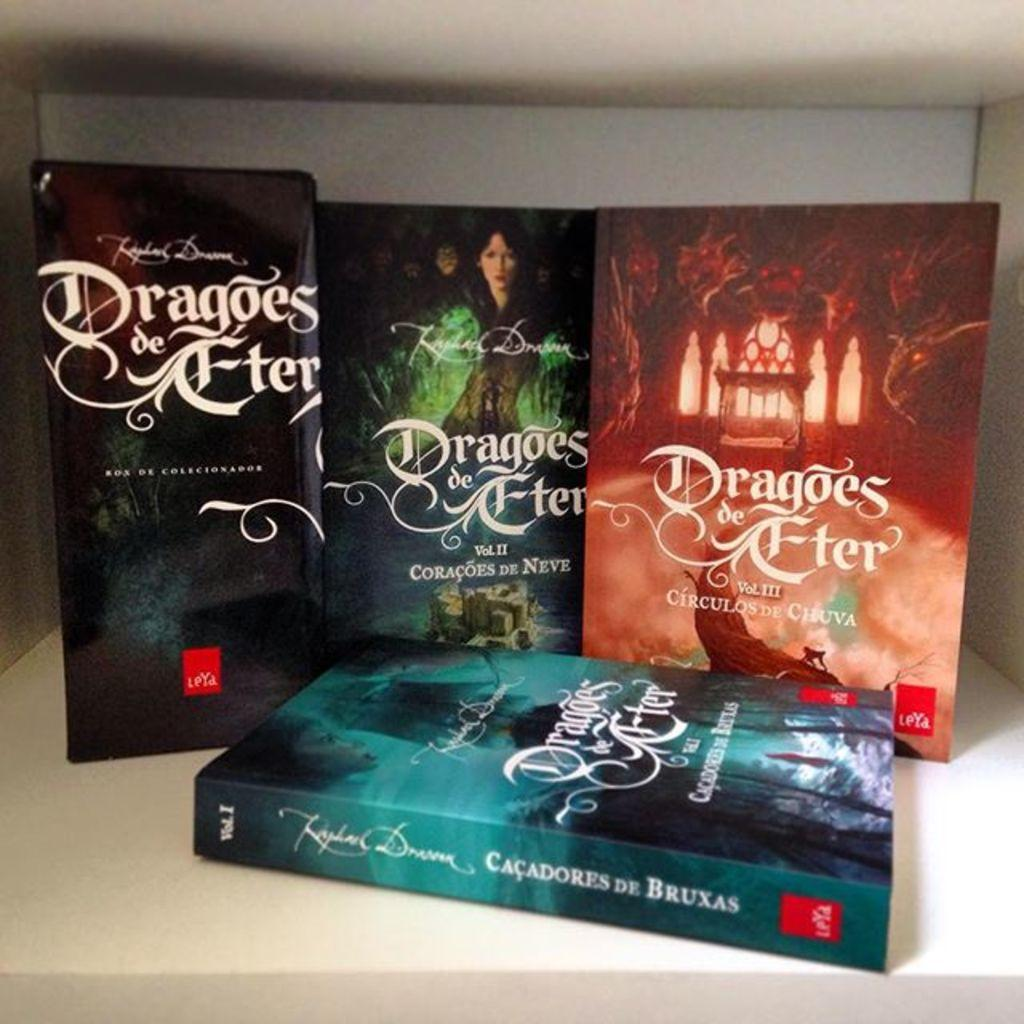Provide a one-sentence caption for the provided image. The book collection of Dragoes de Fter  by Coracoes De Neve. 